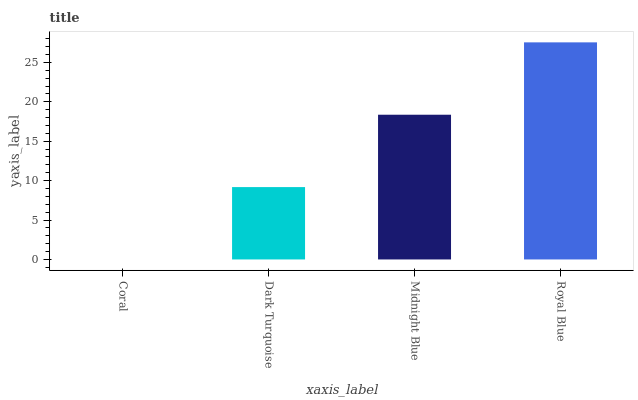Is Dark Turquoise the minimum?
Answer yes or no. No. Is Dark Turquoise the maximum?
Answer yes or no. No. Is Dark Turquoise greater than Coral?
Answer yes or no. Yes. Is Coral less than Dark Turquoise?
Answer yes or no. Yes. Is Coral greater than Dark Turquoise?
Answer yes or no. No. Is Dark Turquoise less than Coral?
Answer yes or no. No. Is Midnight Blue the high median?
Answer yes or no. Yes. Is Dark Turquoise the low median?
Answer yes or no. Yes. Is Coral the high median?
Answer yes or no. No. Is Coral the low median?
Answer yes or no. No. 